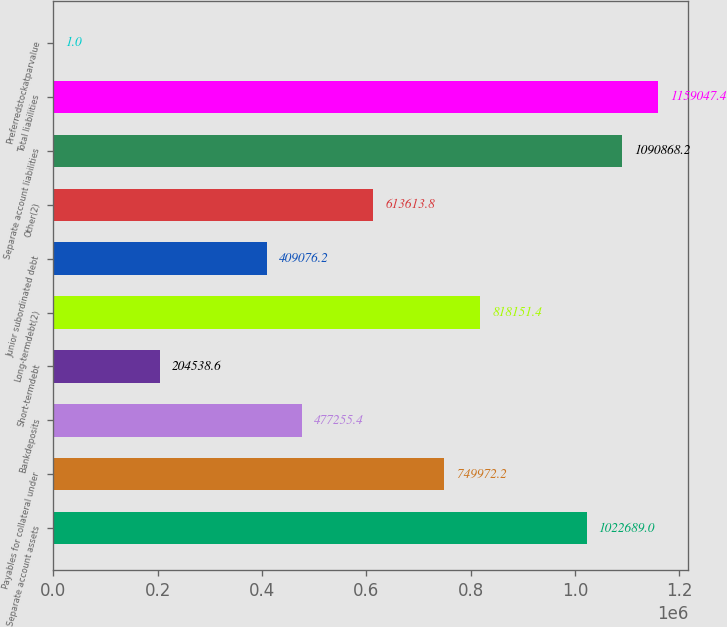Convert chart. <chart><loc_0><loc_0><loc_500><loc_500><bar_chart><fcel>Separate account assets<fcel>Payables for collateral under<fcel>Bankdeposits<fcel>Short-termdebt<fcel>Long-termdebt(2)<fcel>Junior subordinated debt<fcel>Other(2)<fcel>Separate account liabilities<fcel>Total liabilities<fcel>Preferredstockatparvalue<nl><fcel>1.02269e+06<fcel>749972<fcel>477255<fcel>204539<fcel>818151<fcel>409076<fcel>613614<fcel>1.09087e+06<fcel>1.15905e+06<fcel>1<nl></chart> 